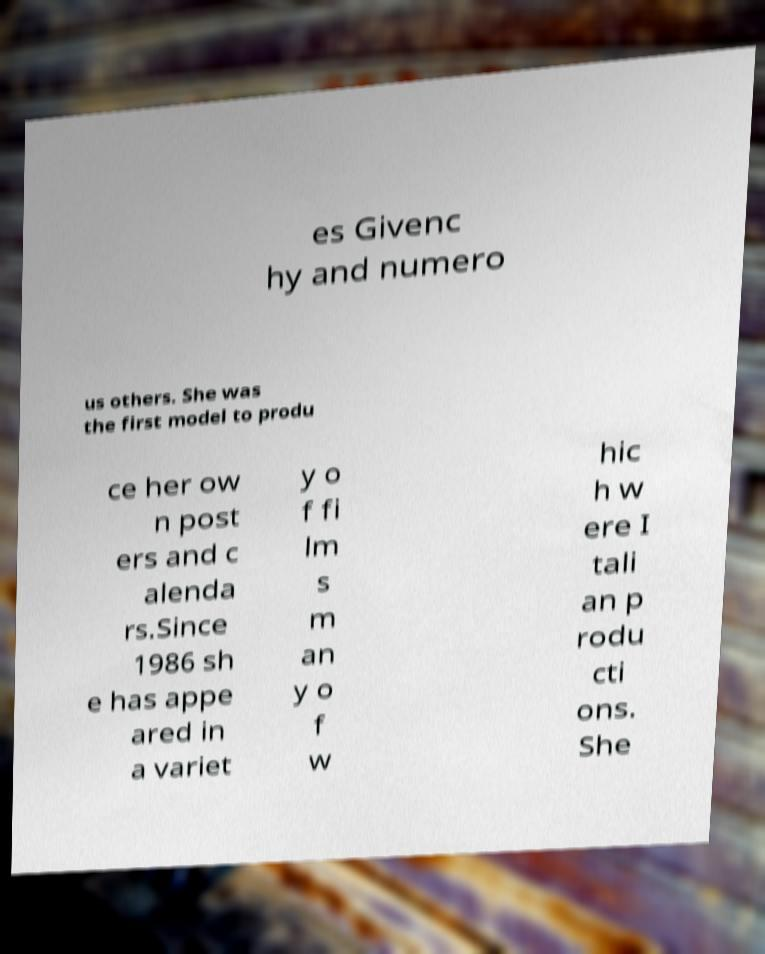Please read and relay the text visible in this image. What does it say? es Givenc hy and numero us others. She was the first model to produ ce her ow n post ers and c alenda rs.Since 1986 sh e has appe ared in a variet y o f fi lm s m an y o f w hic h w ere I tali an p rodu cti ons. She 